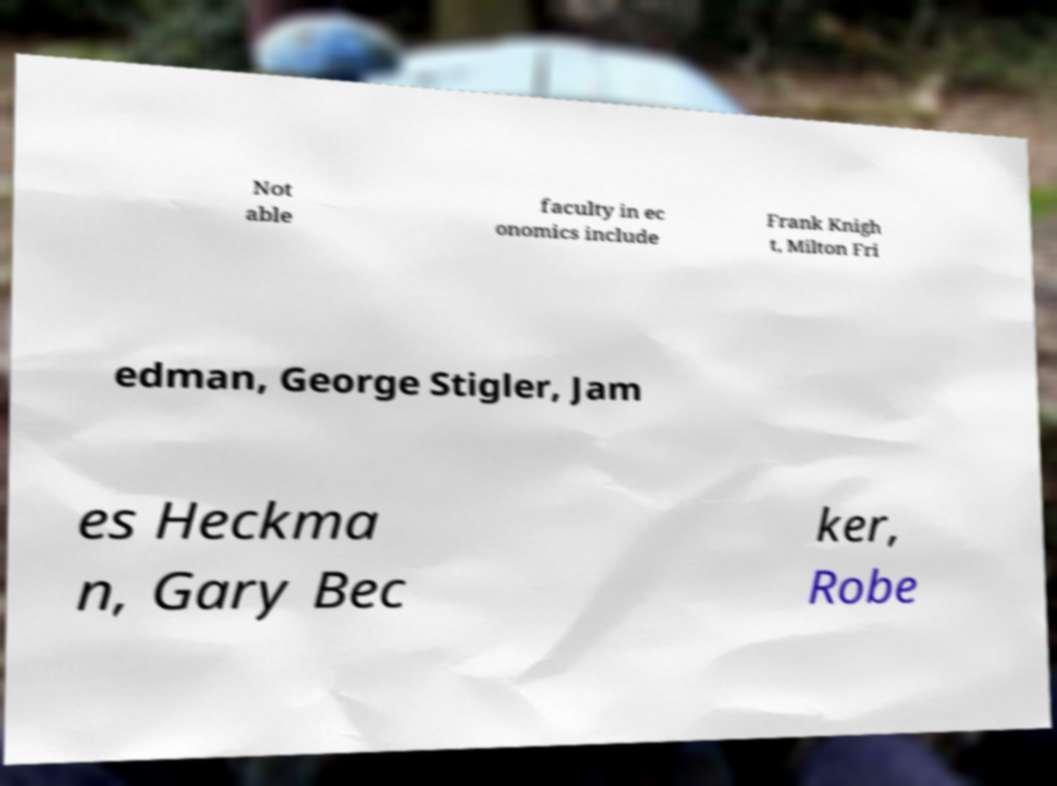Could you assist in decoding the text presented in this image and type it out clearly? Not able faculty in ec onomics include Frank Knigh t, Milton Fri edman, George Stigler, Jam es Heckma n, Gary Bec ker, Robe 